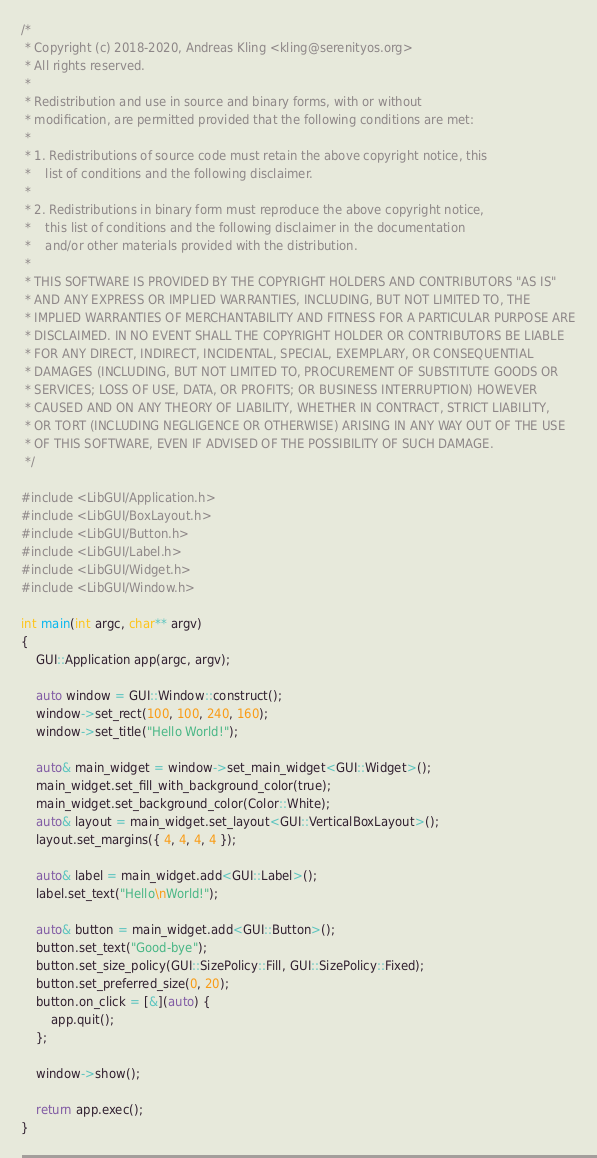<code> <loc_0><loc_0><loc_500><loc_500><_C++_>/*
 * Copyright (c) 2018-2020, Andreas Kling <kling@serenityos.org>
 * All rights reserved.
 *
 * Redistribution and use in source and binary forms, with or without
 * modification, are permitted provided that the following conditions are met:
 *
 * 1. Redistributions of source code must retain the above copyright notice, this
 *    list of conditions and the following disclaimer.
 *
 * 2. Redistributions in binary form must reproduce the above copyright notice,
 *    this list of conditions and the following disclaimer in the documentation
 *    and/or other materials provided with the distribution.
 *
 * THIS SOFTWARE IS PROVIDED BY THE COPYRIGHT HOLDERS AND CONTRIBUTORS "AS IS"
 * AND ANY EXPRESS OR IMPLIED WARRANTIES, INCLUDING, BUT NOT LIMITED TO, THE
 * IMPLIED WARRANTIES OF MERCHANTABILITY AND FITNESS FOR A PARTICULAR PURPOSE ARE
 * DISCLAIMED. IN NO EVENT SHALL THE COPYRIGHT HOLDER OR CONTRIBUTORS BE LIABLE
 * FOR ANY DIRECT, INDIRECT, INCIDENTAL, SPECIAL, EXEMPLARY, OR CONSEQUENTIAL
 * DAMAGES (INCLUDING, BUT NOT LIMITED TO, PROCUREMENT OF SUBSTITUTE GOODS OR
 * SERVICES; LOSS OF USE, DATA, OR PROFITS; OR BUSINESS INTERRUPTION) HOWEVER
 * CAUSED AND ON ANY THEORY OF LIABILITY, WHETHER IN CONTRACT, STRICT LIABILITY,
 * OR TORT (INCLUDING NEGLIGENCE OR OTHERWISE) ARISING IN ANY WAY OUT OF THE USE
 * OF THIS SOFTWARE, EVEN IF ADVISED OF THE POSSIBILITY OF SUCH DAMAGE.
 */

#include <LibGUI/Application.h>
#include <LibGUI/BoxLayout.h>
#include <LibGUI/Button.h>
#include <LibGUI/Label.h>
#include <LibGUI/Widget.h>
#include <LibGUI/Window.h>

int main(int argc, char** argv)
{
    GUI::Application app(argc, argv);

    auto window = GUI::Window::construct();
    window->set_rect(100, 100, 240, 160);
    window->set_title("Hello World!");

    auto& main_widget = window->set_main_widget<GUI::Widget>();
    main_widget.set_fill_with_background_color(true);
    main_widget.set_background_color(Color::White);
    auto& layout = main_widget.set_layout<GUI::VerticalBoxLayout>();
    layout.set_margins({ 4, 4, 4, 4 });

    auto& label = main_widget.add<GUI::Label>();
    label.set_text("Hello\nWorld!");

    auto& button = main_widget.add<GUI::Button>();
    button.set_text("Good-bye");
    button.set_size_policy(GUI::SizePolicy::Fill, GUI::SizePolicy::Fixed);
    button.set_preferred_size(0, 20);
    button.on_click = [&](auto) {
        app.quit();
    };

    window->show();

    return app.exec();
}
</code> 